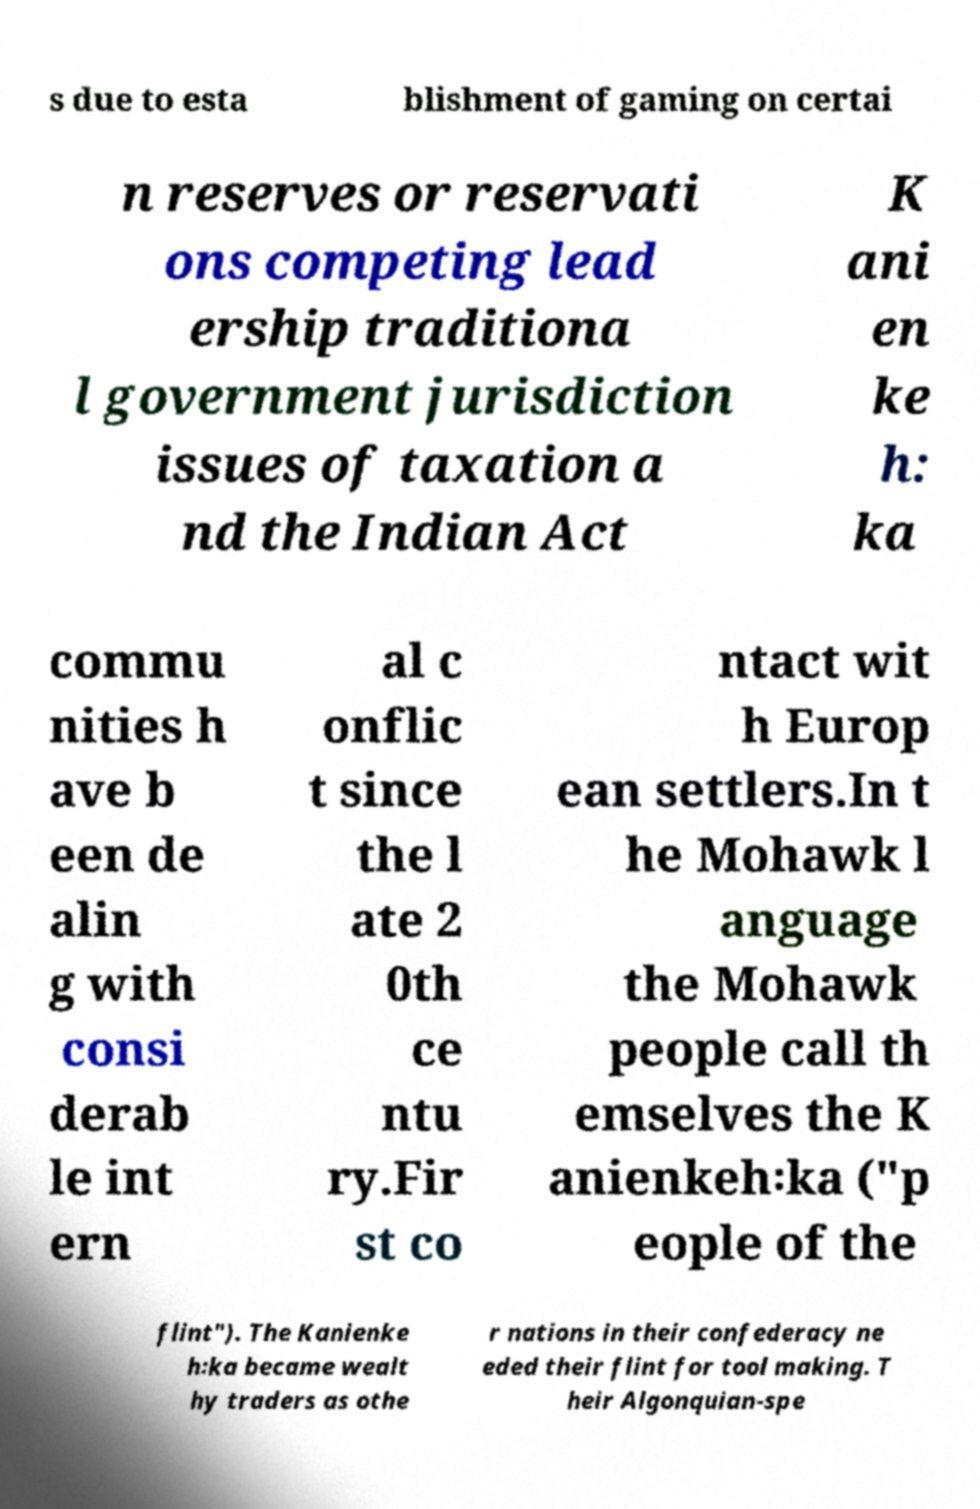Could you extract and type out the text from this image? s due to esta blishment of gaming on certai n reserves or reservati ons competing lead ership traditiona l government jurisdiction issues of taxation a nd the Indian Act K ani en ke h꞉ ka commu nities h ave b een de alin g with consi derab le int ern al c onflic t since the l ate 2 0th ce ntu ry.Fir st co ntact wit h Europ ean settlers.In t he Mohawk l anguage the Mohawk people call th emselves the K anienkeh꞉ka ("p eople of the flint"). The Kanienke h꞉ka became wealt hy traders as othe r nations in their confederacy ne eded their flint for tool making. T heir Algonquian-spe 